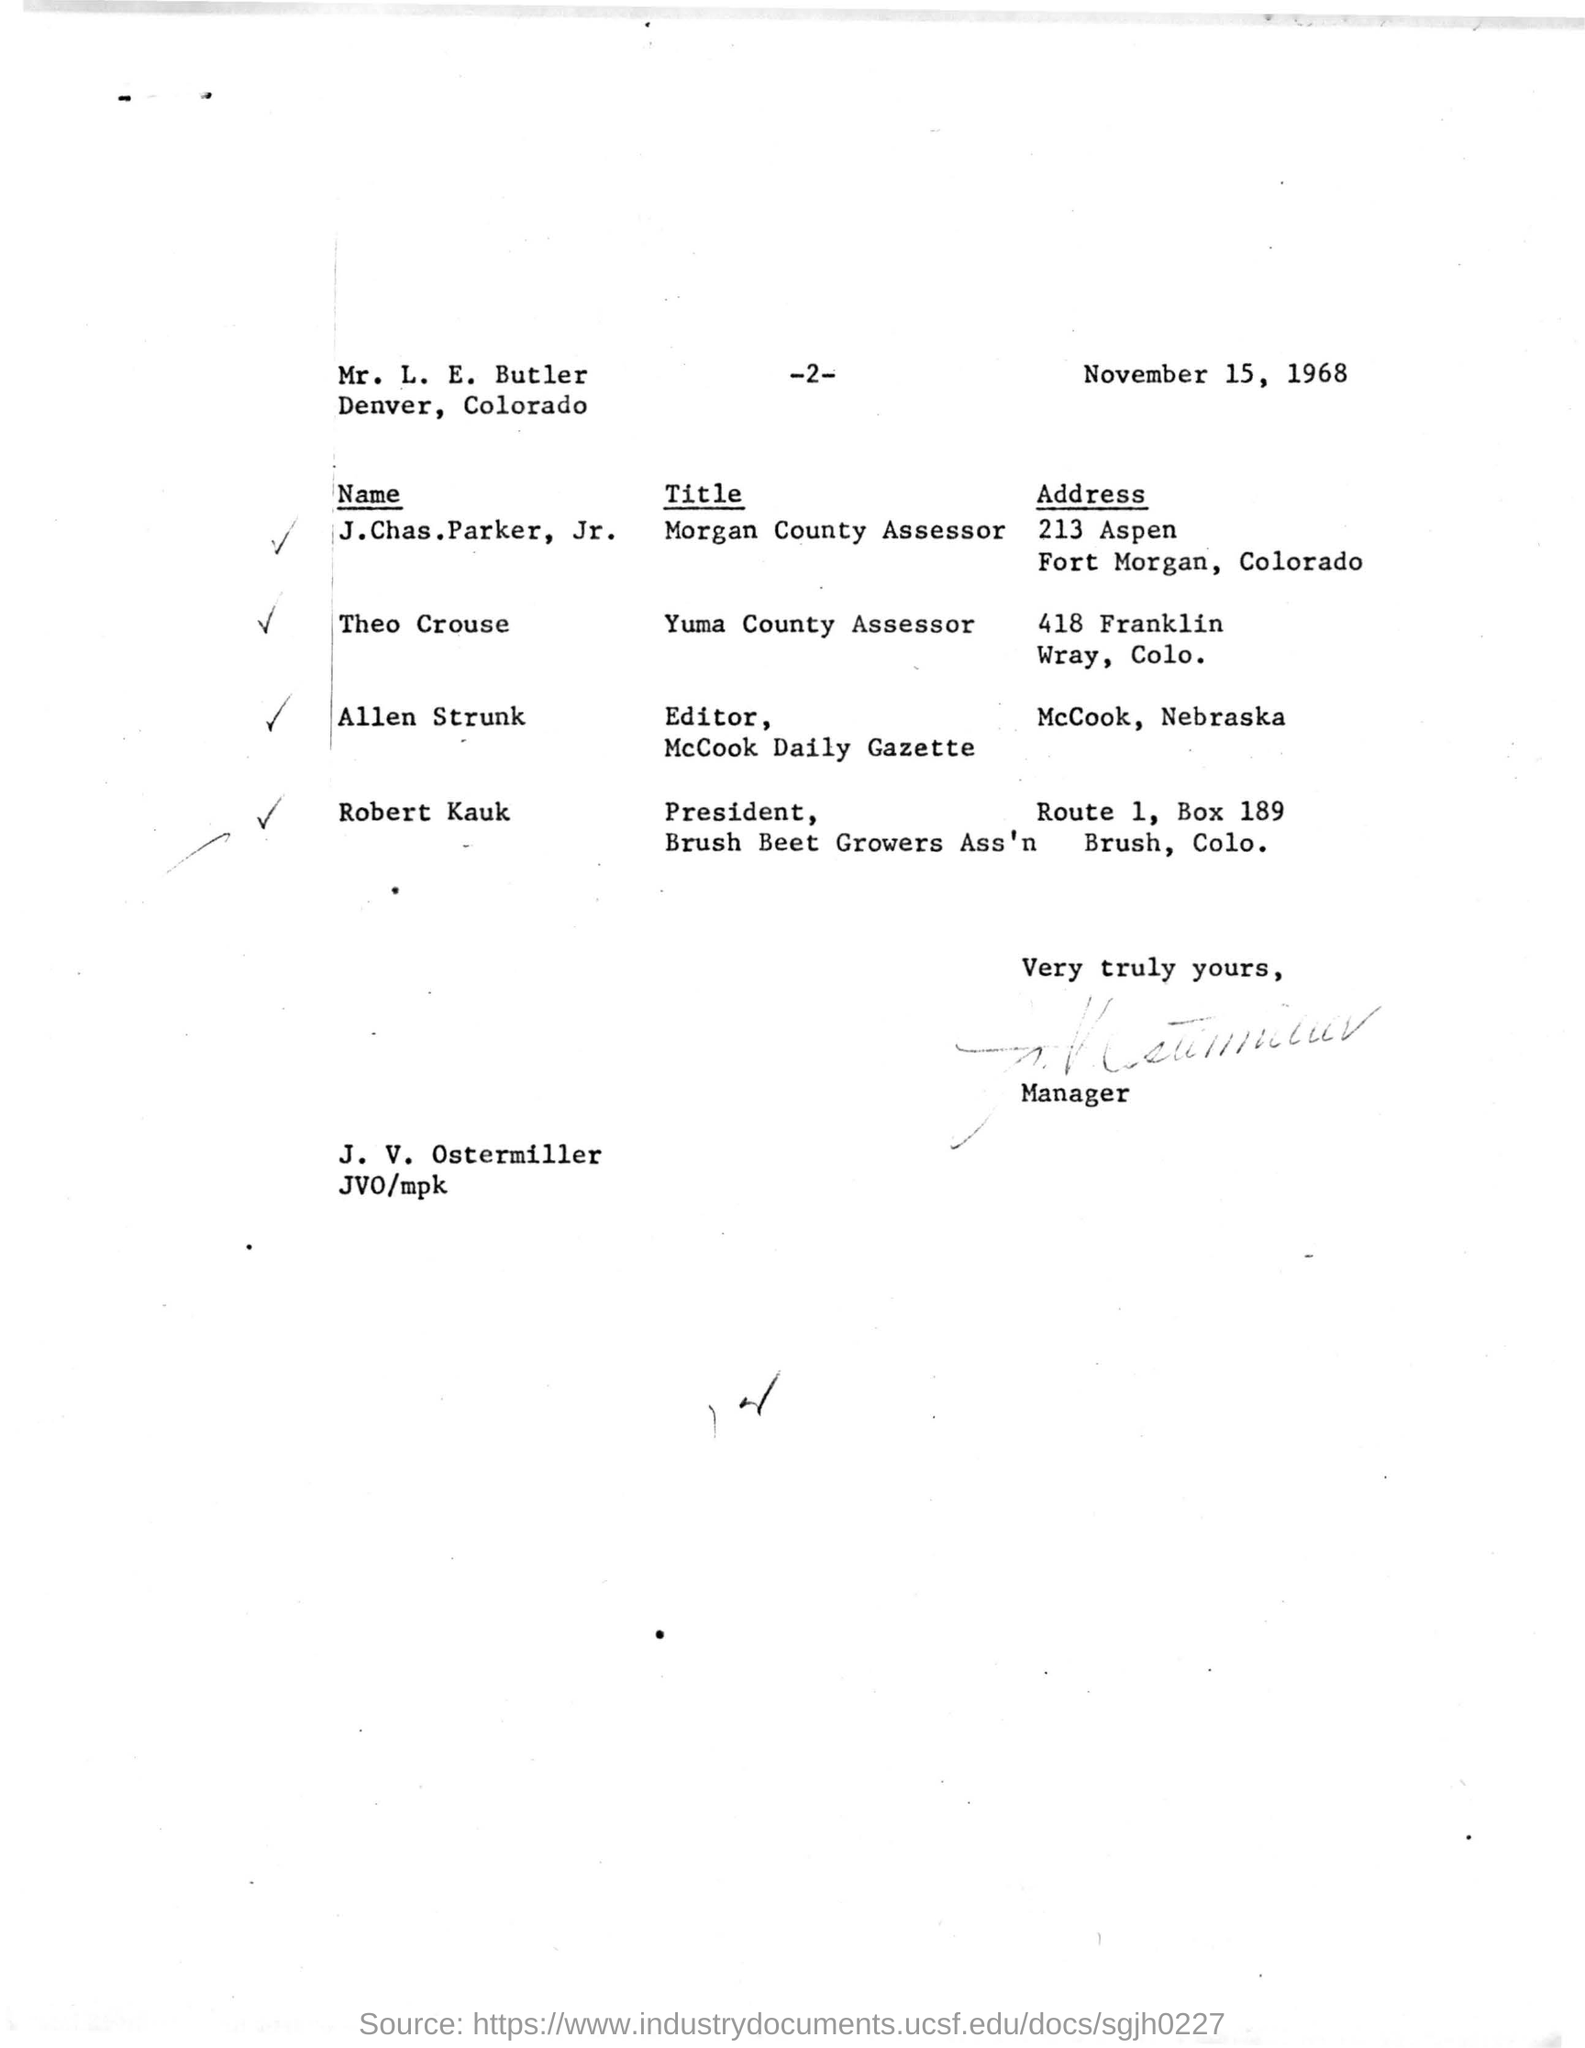What is the address given for the name allen strunk ?
Keep it short and to the point. Mccook, nebraska. What is the title for the name robert kauk ?
Make the answer very short. PRESIDENT, BRUSH BEET GROWERS ASS'N. Name the person with the title yuma county assessor?
Your answer should be very brief. Theo crouse. Who has signed in the given letter ?
Provide a short and direct response. Manager. What is the address given for  robert kauk ?
Offer a very short reply. ROUTE 1, BOX 189 BRUSH COLO. Who is Yuma County Assessor?
Provide a short and direct response. THEO CROUSE. 